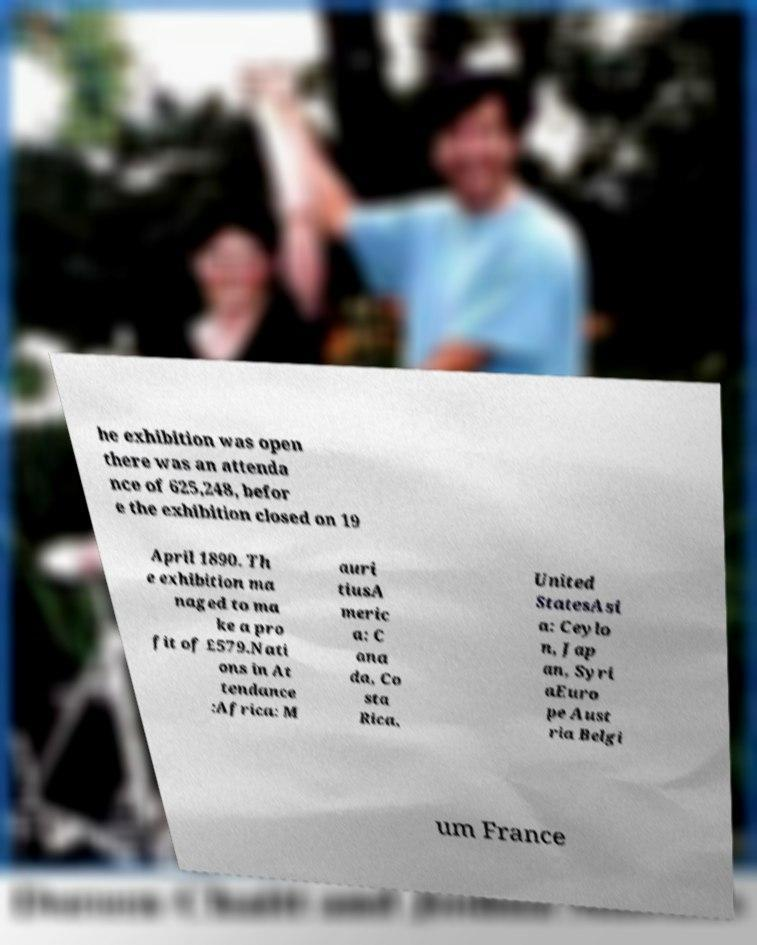Can you read and provide the text displayed in the image?This photo seems to have some interesting text. Can you extract and type it out for me? he exhibition was open there was an attenda nce of 625,248, befor e the exhibition closed on 19 April 1890. Th e exhibition ma naged to ma ke a pro fit of £579.Nati ons in At tendance :Africa: M auri tiusA meric a: C ana da, Co sta Rica, United StatesAsi a: Ceylo n, Jap an, Syri aEuro pe Aust ria Belgi um France 